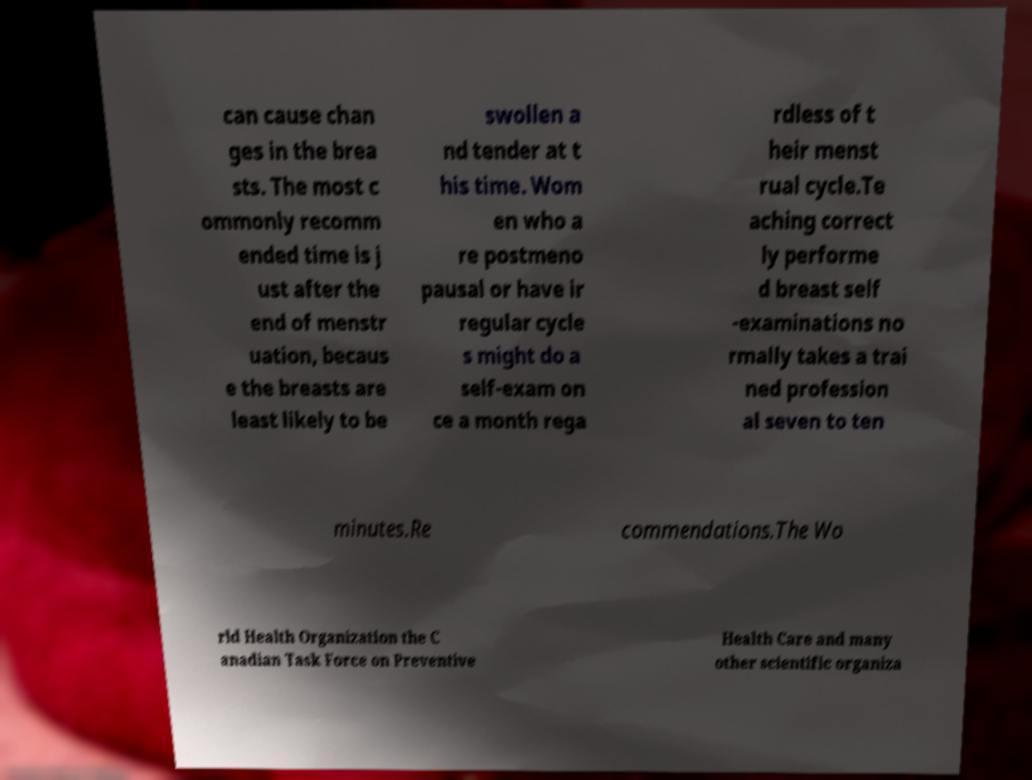For documentation purposes, I need the text within this image transcribed. Could you provide that? can cause chan ges in the brea sts. The most c ommonly recomm ended time is j ust after the end of menstr uation, becaus e the breasts are least likely to be swollen a nd tender at t his time. Wom en who a re postmeno pausal or have ir regular cycle s might do a self-exam on ce a month rega rdless of t heir menst rual cycle.Te aching correct ly performe d breast self -examinations no rmally takes a trai ned profession al seven to ten minutes.Re commendations.The Wo rld Health Organization the C anadian Task Force on Preventive Health Care and many other scientific organiza 